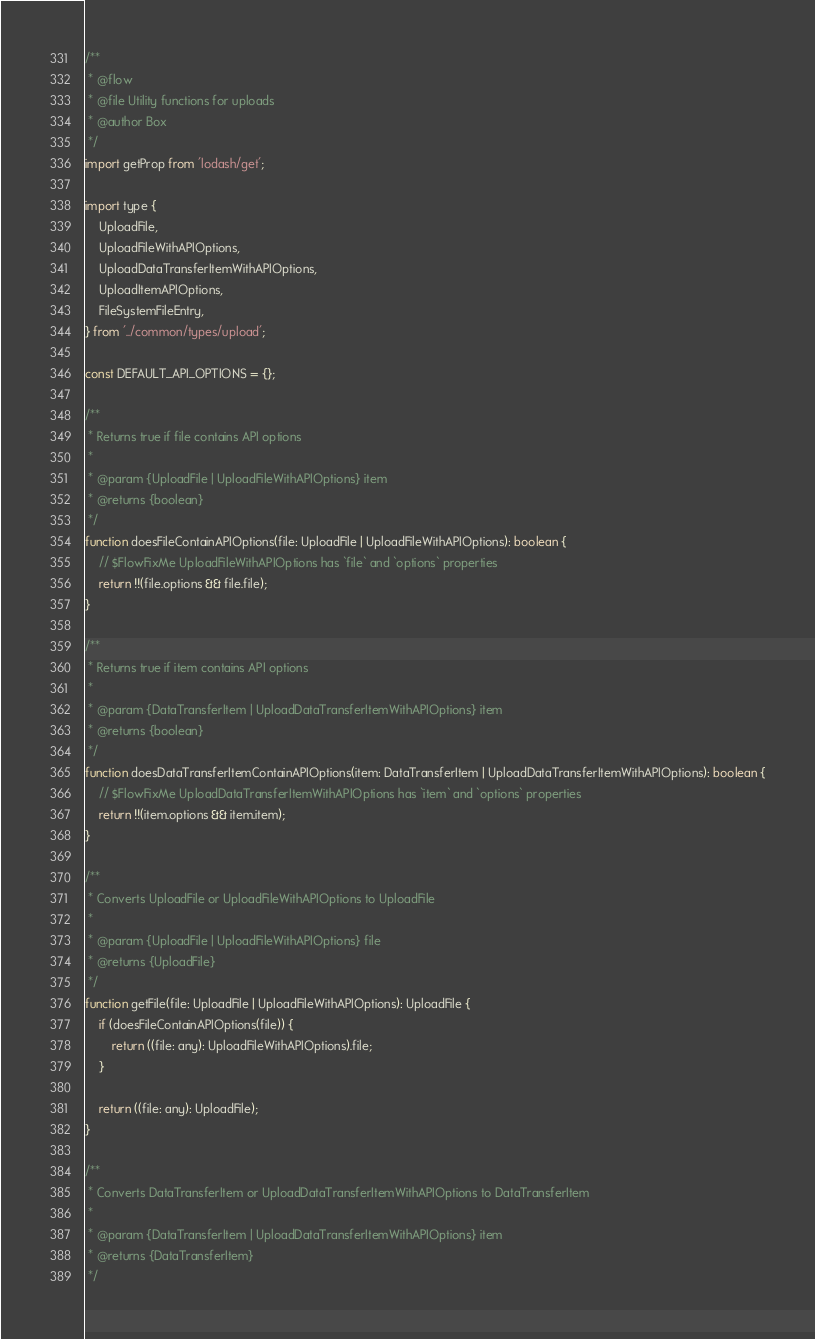<code> <loc_0><loc_0><loc_500><loc_500><_JavaScript_>/**
 * @flow
 * @file Utility functions for uploads
 * @author Box
 */
import getProp from 'lodash/get';

import type {
    UploadFile,
    UploadFileWithAPIOptions,
    UploadDataTransferItemWithAPIOptions,
    UploadItemAPIOptions,
    FileSystemFileEntry,
} from '../common/types/upload';

const DEFAULT_API_OPTIONS = {};

/**
 * Returns true if file contains API options
 *
 * @param {UploadFile | UploadFileWithAPIOptions} item
 * @returns {boolean}
 */
function doesFileContainAPIOptions(file: UploadFile | UploadFileWithAPIOptions): boolean {
    // $FlowFixMe UploadFileWithAPIOptions has `file` and `options` properties
    return !!(file.options && file.file);
}

/**
 * Returns true if item contains API options
 *
 * @param {DataTransferItem | UploadDataTransferItemWithAPIOptions} item
 * @returns {boolean}
 */
function doesDataTransferItemContainAPIOptions(item: DataTransferItem | UploadDataTransferItemWithAPIOptions): boolean {
    // $FlowFixMe UploadDataTransferItemWithAPIOptions has `item` and `options` properties
    return !!(item.options && item.item);
}

/**
 * Converts UploadFile or UploadFileWithAPIOptions to UploadFile
 *
 * @param {UploadFile | UploadFileWithAPIOptions} file
 * @returns {UploadFile}
 */
function getFile(file: UploadFile | UploadFileWithAPIOptions): UploadFile {
    if (doesFileContainAPIOptions(file)) {
        return ((file: any): UploadFileWithAPIOptions).file;
    }

    return ((file: any): UploadFile);
}

/**
 * Converts DataTransferItem or UploadDataTransferItemWithAPIOptions to DataTransferItem
 *
 * @param {DataTransferItem | UploadDataTransferItemWithAPIOptions} item
 * @returns {DataTransferItem}
 */</code> 